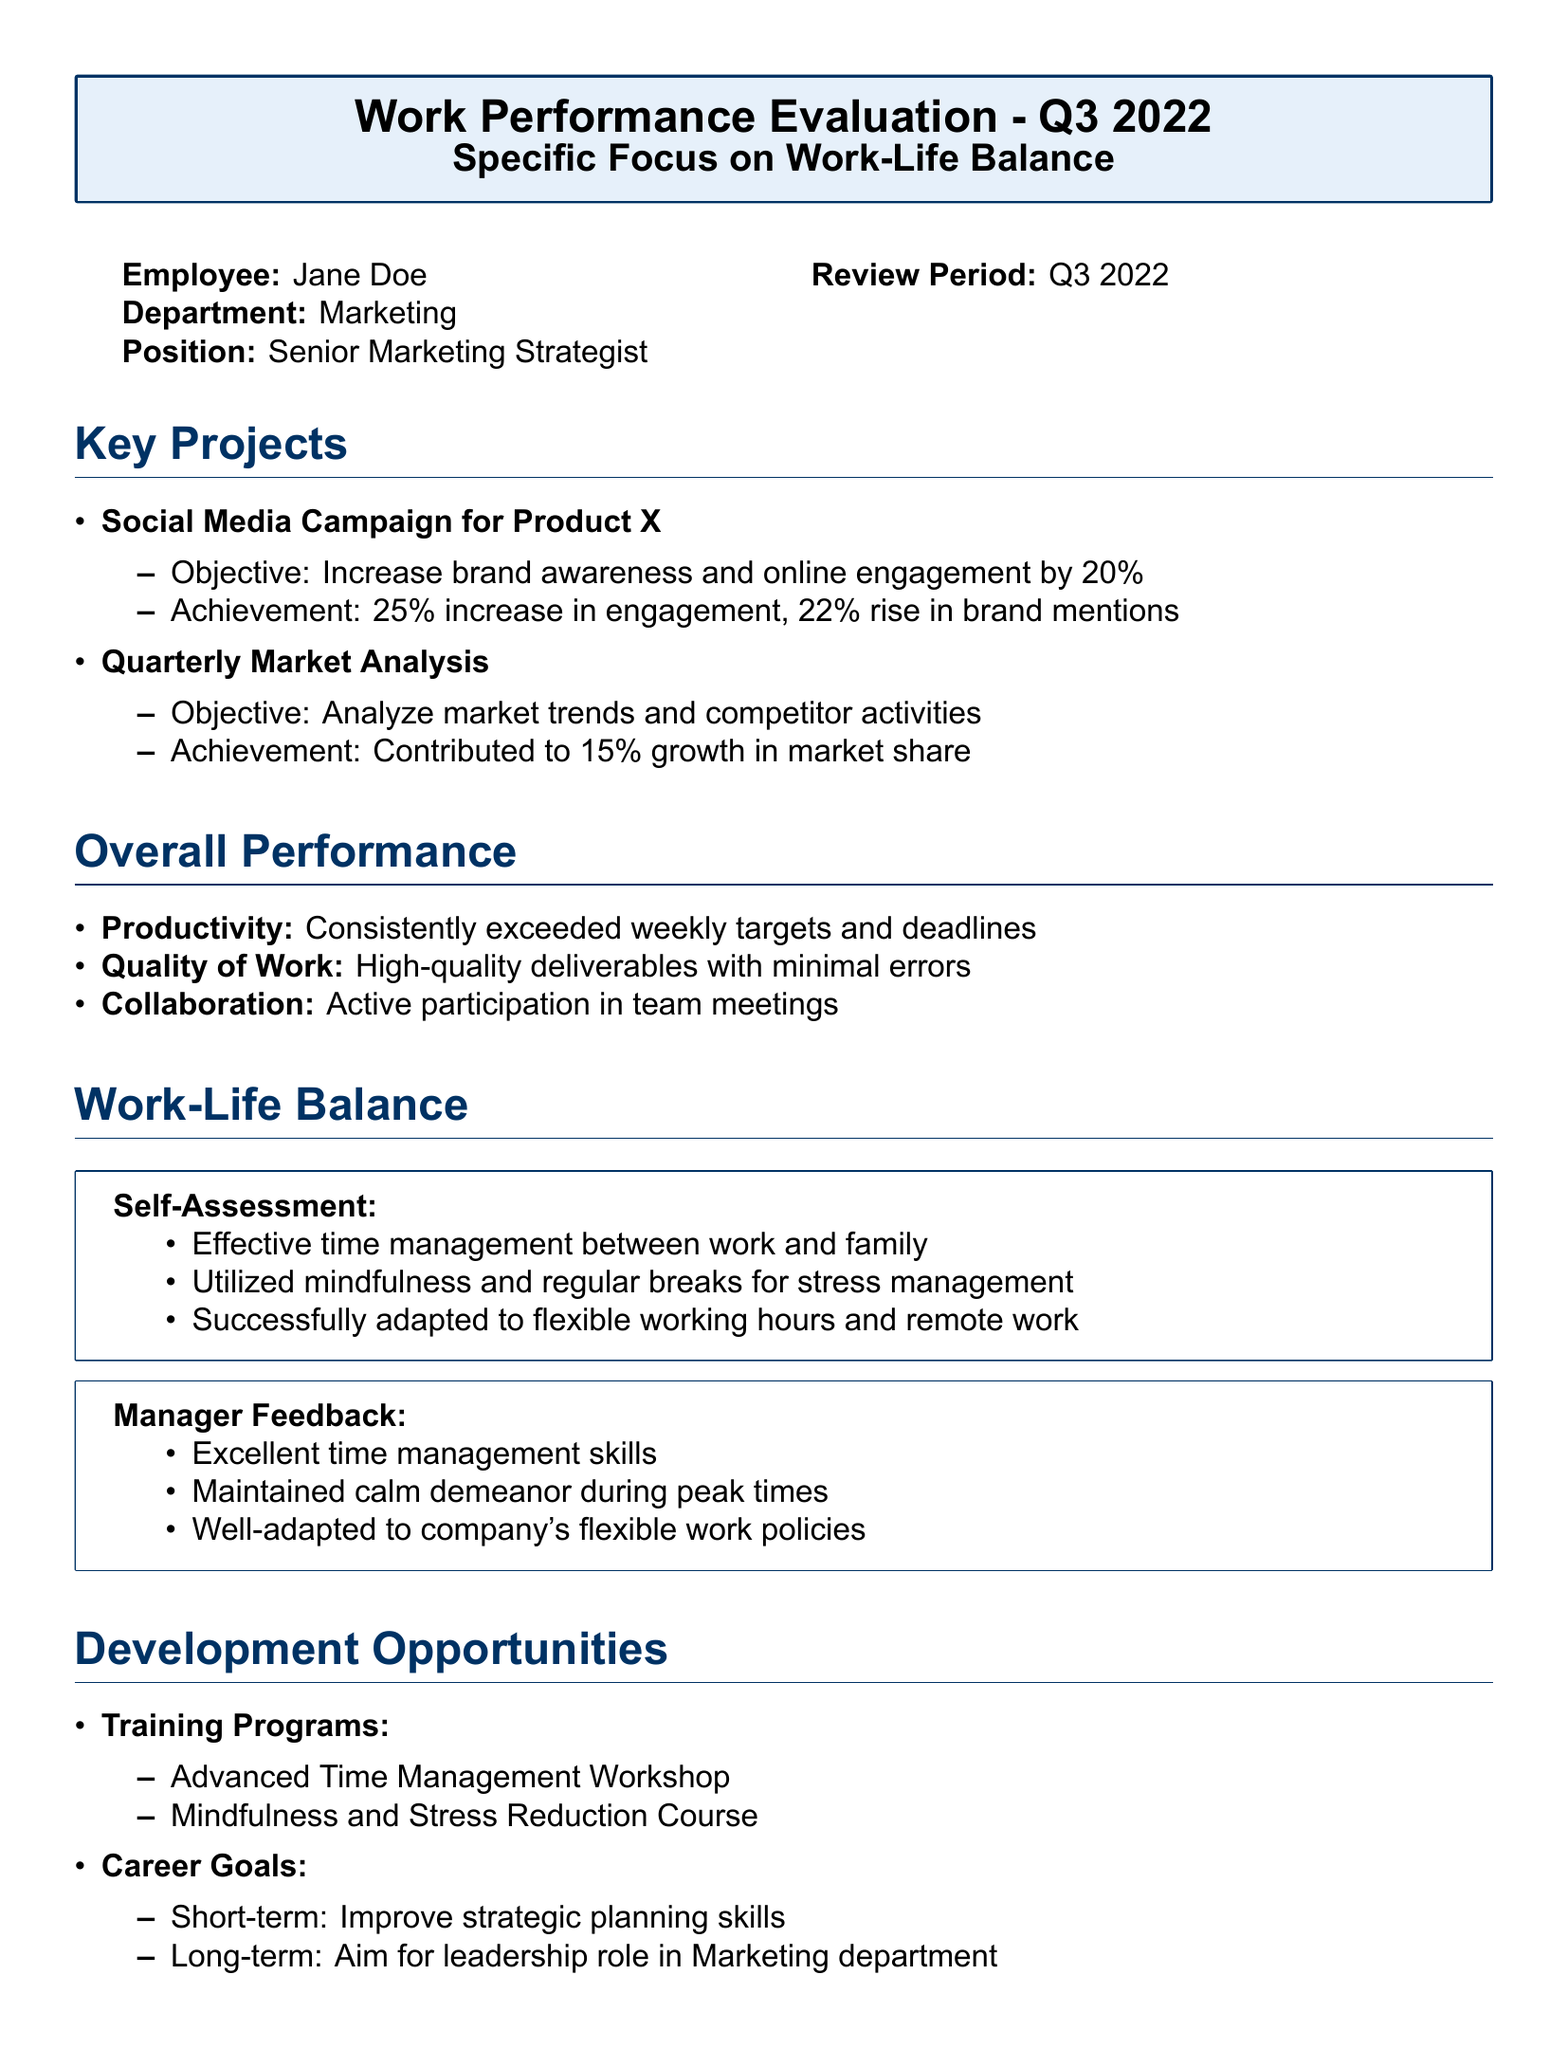what is the name of the employee? The document explicitly states that the employee being evaluated is Jane Doe.
Answer: Jane Doe which department does the employee work in? The department listed in the document for the employee is Marketing.
Answer: Marketing what was the percentage increase in engagement from the Social Media Campaign? The document indicates the engagement from the campaign increased by 25%.
Answer: 25% what training programs are suggested for development? The suggested training programs listed in the document are Advanced Time Management Workshop and Mindfulness and Stress Reduction Course.
Answer: Advanced Time Management Workshop, Mindfulness and Stress Reduction Course how did the manager describe the employee's time management skills? The manager feedback notes that Jane has excellent time management skills.
Answer: Excellent time management skills what is the short-term career goal mentioned in the document? The document specifies that the short-term career goal is to improve strategic planning skills.
Answer: Improve strategic planning skills how did the employee self-assess their time management? The self-assessment states that they effectively manage time between work and family.
Answer: Effective time management between work and family what was the achievement of the Quarterly Market Analysis project? The document indicates that the achievement was a 15% growth in market share.
Answer: 15% growth in market share how does the employee feel about the work-life balance? The employee comments that they are satisfied with the work-life balance.
Answer: Satisfied with work-life balance 